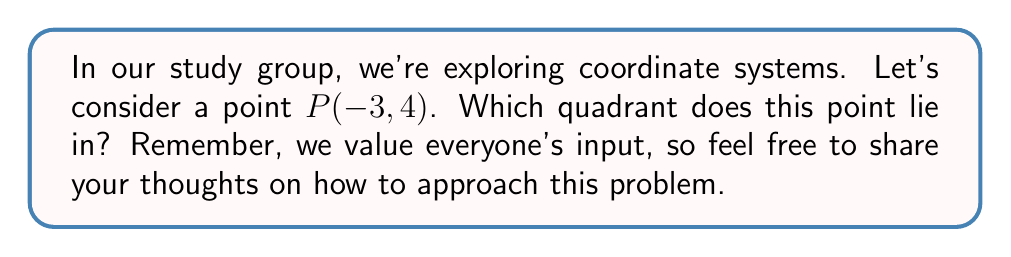Can you answer this question? To determine the quadrant of a point, we need to consider the signs of its x and y coordinates. Let's break this down step-by-step:

1) The coordinates of point $P$ are $(-3, 4)$.

2) The x-coordinate is -3, which is negative.
3) The y-coordinate is 4, which is positive.

4) Recall the quadrant rules:
   - Quadrant I: $(+, +)$
   - Quadrant II: $(-, +)$
   - Quadrant III: $(-, -)$
   - Quadrant IV: $(+, -)$

5) Since we have a negative x-coordinate and a positive y-coordinate, this matches the pattern for Quadrant II.

To visualize this:

[asy]
import graph;
size(200);
xaxis("x");
yaxis("y");
dot((-3,4),red);
label("P(-3, 4)", (-3,4), NE);
[/asy]

The point $P(-3, 4)$ is indeed in the upper-left quadrant, which is Quadrant II.
Answer: Quadrant II 